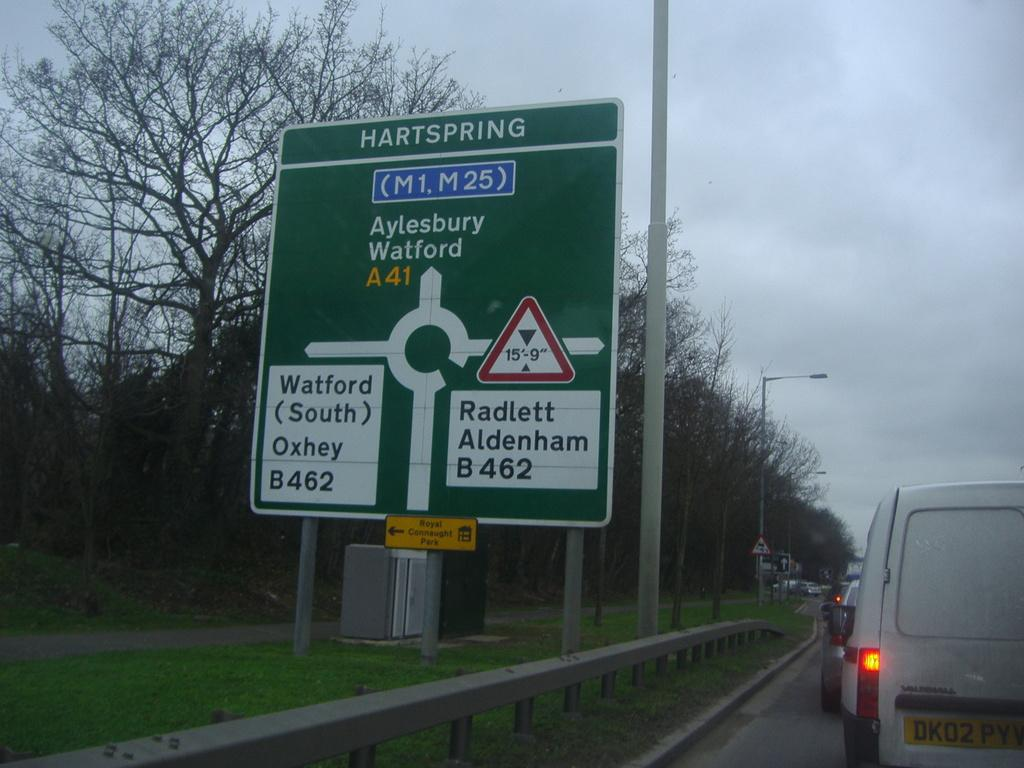<image>
Create a compact narrative representing the image presented. A green and white sign with Hartspring at the top 